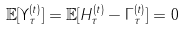<formula> <loc_0><loc_0><loc_500><loc_500>\mathbb { E } [ \Upsilon _ { \tau } ^ { ( t ) } ] = \mathbb { E } [ H _ { \tau } ^ { ( t ) } - \Gamma _ { \tau } ^ { ( t ) } ] = 0</formula> 